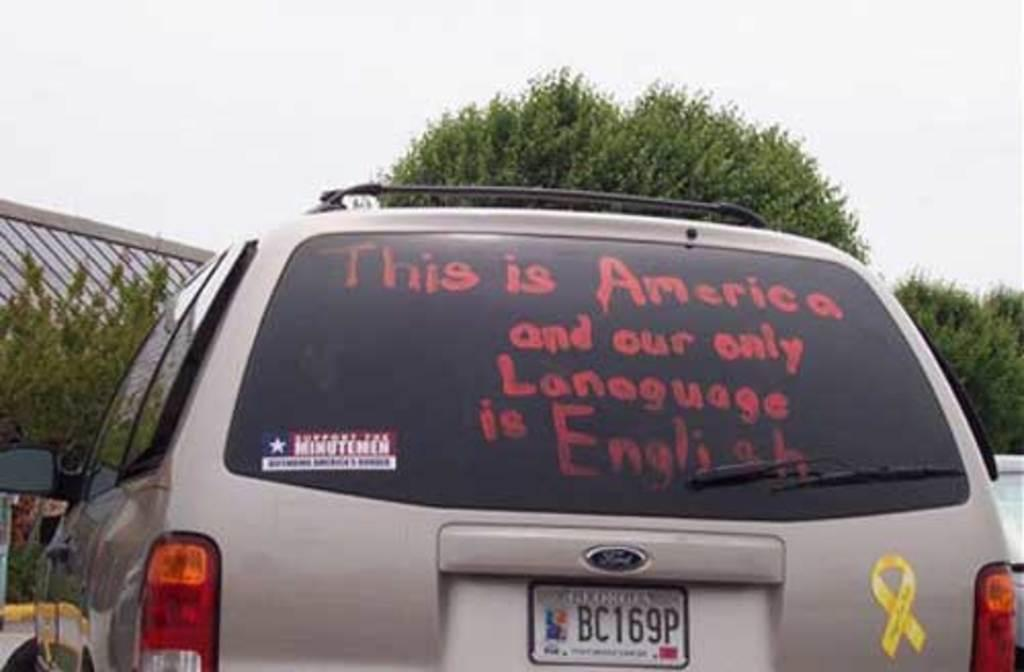<image>
Give a short and clear explanation of the subsequent image. Image displays silver vehicle with the text "This is America and your only language is English" written on the rear view window. 